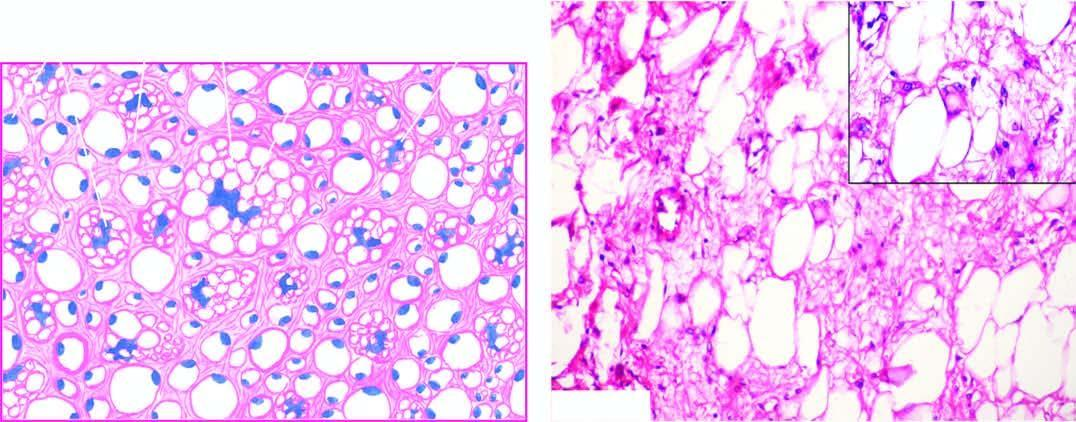what shows close-up view of a typical lipoblast having multivacuolated cytoplasm indenting the atypical nucleus?
Answer the question using a single word or phrase. Inset in the right photomicrograph 